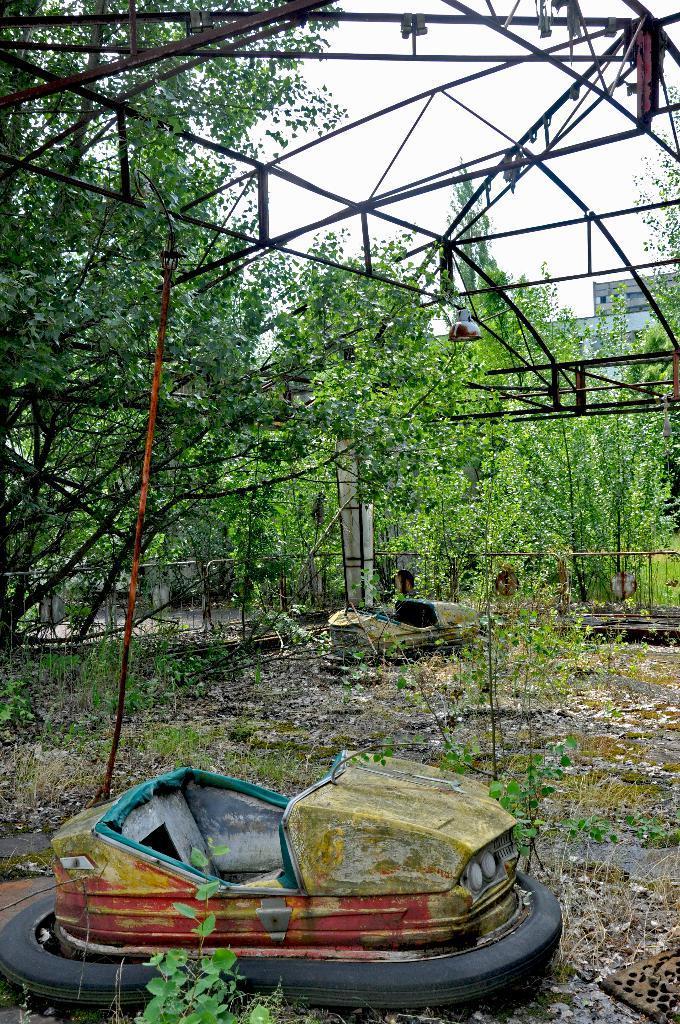Could you give a brief overview of what you see in this image? There are a lot of trees in an area and in between the trees there are many iron rods attached to one another and on the ground there is a lot of waste and an old toy car, the place is very messy and in the background there is a sky. 